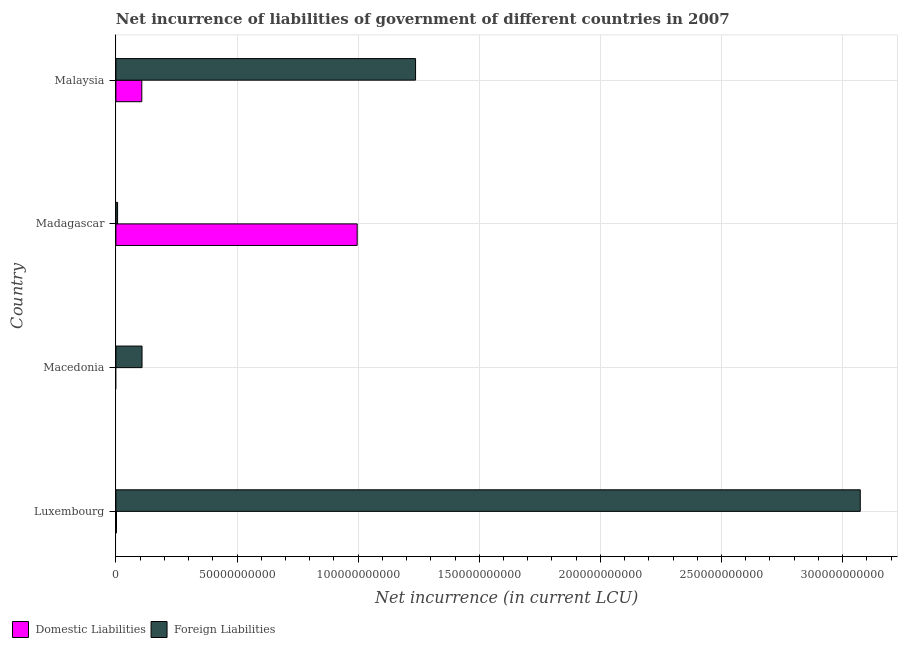How many different coloured bars are there?
Offer a terse response. 2. Are the number of bars per tick equal to the number of legend labels?
Your answer should be very brief. No. How many bars are there on the 2nd tick from the top?
Provide a short and direct response. 2. What is the label of the 2nd group of bars from the top?
Make the answer very short. Madagascar. In how many cases, is the number of bars for a given country not equal to the number of legend labels?
Your response must be concise. 1. What is the net incurrence of domestic liabilities in Malaysia?
Keep it short and to the point. 1.07e+1. Across all countries, what is the maximum net incurrence of foreign liabilities?
Offer a terse response. 3.07e+11. Across all countries, what is the minimum net incurrence of foreign liabilities?
Give a very brief answer. 6.97e+08. In which country was the net incurrence of domestic liabilities maximum?
Your response must be concise. Madagascar. What is the total net incurrence of domestic liabilities in the graph?
Your answer should be compact. 1.11e+11. What is the difference between the net incurrence of foreign liabilities in Madagascar and that in Malaysia?
Offer a terse response. -1.23e+11. What is the difference between the net incurrence of domestic liabilities in Malaysia and the net incurrence of foreign liabilities in Macedonia?
Your response must be concise. -9.14e+07. What is the average net incurrence of domestic liabilities per country?
Offer a terse response. 2.76e+1. What is the difference between the net incurrence of foreign liabilities and net incurrence of domestic liabilities in Madagascar?
Your answer should be compact. -9.89e+1. In how many countries, is the net incurrence of domestic liabilities greater than 240000000000 LCU?
Make the answer very short. 0. What is the ratio of the net incurrence of foreign liabilities in Luxembourg to that in Madagascar?
Provide a succinct answer. 440.64. What is the difference between the highest and the second highest net incurrence of domestic liabilities?
Ensure brevity in your answer.  8.89e+1. What is the difference between the highest and the lowest net incurrence of foreign liabilities?
Keep it short and to the point. 3.07e+11. In how many countries, is the net incurrence of foreign liabilities greater than the average net incurrence of foreign liabilities taken over all countries?
Your response must be concise. 2. What is the difference between two consecutive major ticks on the X-axis?
Make the answer very short. 5.00e+1. Are the values on the major ticks of X-axis written in scientific E-notation?
Your answer should be very brief. No. Where does the legend appear in the graph?
Give a very brief answer. Bottom left. How many legend labels are there?
Provide a succinct answer. 2. What is the title of the graph?
Offer a terse response. Net incurrence of liabilities of government of different countries in 2007. Does "Formally registered" appear as one of the legend labels in the graph?
Your response must be concise. No. What is the label or title of the X-axis?
Ensure brevity in your answer.  Net incurrence (in current LCU). What is the Net incurrence (in current LCU) in Domestic Liabilities in Luxembourg?
Offer a terse response. 2.44e+08. What is the Net incurrence (in current LCU) of Foreign Liabilities in Luxembourg?
Your response must be concise. 3.07e+11. What is the Net incurrence (in current LCU) in Domestic Liabilities in Macedonia?
Give a very brief answer. 0. What is the Net incurrence (in current LCU) of Foreign Liabilities in Macedonia?
Offer a very short reply. 1.08e+1. What is the Net incurrence (in current LCU) of Domestic Liabilities in Madagascar?
Provide a succinct answer. 9.96e+1. What is the Net incurrence (in current LCU) of Foreign Liabilities in Madagascar?
Make the answer very short. 6.97e+08. What is the Net incurrence (in current LCU) of Domestic Liabilities in Malaysia?
Your answer should be compact. 1.07e+1. What is the Net incurrence (in current LCU) in Foreign Liabilities in Malaysia?
Your answer should be compact. 1.24e+11. Across all countries, what is the maximum Net incurrence (in current LCU) in Domestic Liabilities?
Provide a short and direct response. 9.96e+1. Across all countries, what is the maximum Net incurrence (in current LCU) in Foreign Liabilities?
Give a very brief answer. 3.07e+11. Across all countries, what is the minimum Net incurrence (in current LCU) in Domestic Liabilities?
Provide a short and direct response. 0. Across all countries, what is the minimum Net incurrence (in current LCU) of Foreign Liabilities?
Ensure brevity in your answer.  6.97e+08. What is the total Net incurrence (in current LCU) of Domestic Liabilities in the graph?
Offer a very short reply. 1.11e+11. What is the total Net incurrence (in current LCU) in Foreign Liabilities in the graph?
Your answer should be very brief. 4.42e+11. What is the difference between the Net incurrence (in current LCU) in Foreign Liabilities in Luxembourg and that in Macedonia?
Give a very brief answer. 2.96e+11. What is the difference between the Net incurrence (in current LCU) of Domestic Liabilities in Luxembourg and that in Madagascar?
Keep it short and to the point. -9.94e+1. What is the difference between the Net incurrence (in current LCU) in Foreign Liabilities in Luxembourg and that in Madagascar?
Offer a terse response. 3.07e+11. What is the difference between the Net incurrence (in current LCU) of Domestic Liabilities in Luxembourg and that in Malaysia?
Make the answer very short. -1.05e+1. What is the difference between the Net incurrence (in current LCU) in Foreign Liabilities in Luxembourg and that in Malaysia?
Ensure brevity in your answer.  1.84e+11. What is the difference between the Net incurrence (in current LCU) in Foreign Liabilities in Macedonia and that in Madagascar?
Keep it short and to the point. 1.01e+1. What is the difference between the Net incurrence (in current LCU) in Foreign Liabilities in Macedonia and that in Malaysia?
Offer a very short reply. -1.13e+11. What is the difference between the Net incurrence (in current LCU) of Domestic Liabilities in Madagascar and that in Malaysia?
Ensure brevity in your answer.  8.89e+1. What is the difference between the Net incurrence (in current LCU) in Foreign Liabilities in Madagascar and that in Malaysia?
Provide a succinct answer. -1.23e+11. What is the difference between the Net incurrence (in current LCU) of Domestic Liabilities in Luxembourg and the Net incurrence (in current LCU) of Foreign Liabilities in Macedonia?
Provide a succinct answer. -1.05e+1. What is the difference between the Net incurrence (in current LCU) in Domestic Liabilities in Luxembourg and the Net incurrence (in current LCU) in Foreign Liabilities in Madagascar?
Your answer should be compact. -4.53e+08. What is the difference between the Net incurrence (in current LCU) of Domestic Liabilities in Luxembourg and the Net incurrence (in current LCU) of Foreign Liabilities in Malaysia?
Provide a short and direct response. -1.23e+11. What is the difference between the Net incurrence (in current LCU) in Domestic Liabilities in Madagascar and the Net incurrence (in current LCU) in Foreign Liabilities in Malaysia?
Keep it short and to the point. -2.41e+1. What is the average Net incurrence (in current LCU) of Domestic Liabilities per country?
Ensure brevity in your answer.  2.76e+1. What is the average Net incurrence (in current LCU) of Foreign Liabilities per country?
Your response must be concise. 1.11e+11. What is the difference between the Net incurrence (in current LCU) in Domestic Liabilities and Net incurrence (in current LCU) in Foreign Liabilities in Luxembourg?
Ensure brevity in your answer.  -3.07e+11. What is the difference between the Net incurrence (in current LCU) in Domestic Liabilities and Net incurrence (in current LCU) in Foreign Liabilities in Madagascar?
Your answer should be very brief. 9.89e+1. What is the difference between the Net incurrence (in current LCU) of Domestic Liabilities and Net incurrence (in current LCU) of Foreign Liabilities in Malaysia?
Ensure brevity in your answer.  -1.13e+11. What is the ratio of the Net incurrence (in current LCU) in Foreign Liabilities in Luxembourg to that in Macedonia?
Your response must be concise. 28.48. What is the ratio of the Net incurrence (in current LCU) in Domestic Liabilities in Luxembourg to that in Madagascar?
Ensure brevity in your answer.  0. What is the ratio of the Net incurrence (in current LCU) in Foreign Liabilities in Luxembourg to that in Madagascar?
Your response must be concise. 440.64. What is the ratio of the Net incurrence (in current LCU) of Domestic Liabilities in Luxembourg to that in Malaysia?
Offer a very short reply. 0.02. What is the ratio of the Net incurrence (in current LCU) of Foreign Liabilities in Luxembourg to that in Malaysia?
Your response must be concise. 2.48. What is the ratio of the Net incurrence (in current LCU) of Foreign Liabilities in Macedonia to that in Madagascar?
Your answer should be compact. 15.47. What is the ratio of the Net incurrence (in current LCU) of Foreign Liabilities in Macedonia to that in Malaysia?
Provide a succinct answer. 0.09. What is the ratio of the Net incurrence (in current LCU) of Domestic Liabilities in Madagascar to that in Malaysia?
Make the answer very short. 9.31. What is the ratio of the Net incurrence (in current LCU) in Foreign Liabilities in Madagascar to that in Malaysia?
Keep it short and to the point. 0.01. What is the difference between the highest and the second highest Net incurrence (in current LCU) of Domestic Liabilities?
Your response must be concise. 8.89e+1. What is the difference between the highest and the second highest Net incurrence (in current LCU) in Foreign Liabilities?
Give a very brief answer. 1.84e+11. What is the difference between the highest and the lowest Net incurrence (in current LCU) of Domestic Liabilities?
Your answer should be compact. 9.96e+1. What is the difference between the highest and the lowest Net incurrence (in current LCU) of Foreign Liabilities?
Ensure brevity in your answer.  3.07e+11. 